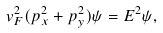<formula> <loc_0><loc_0><loc_500><loc_500>v _ { F } ^ { 2 } ( p _ { x } ^ { 2 } + p _ { y } ^ { 2 } ) \psi = E ^ { 2 } \psi ,</formula> 